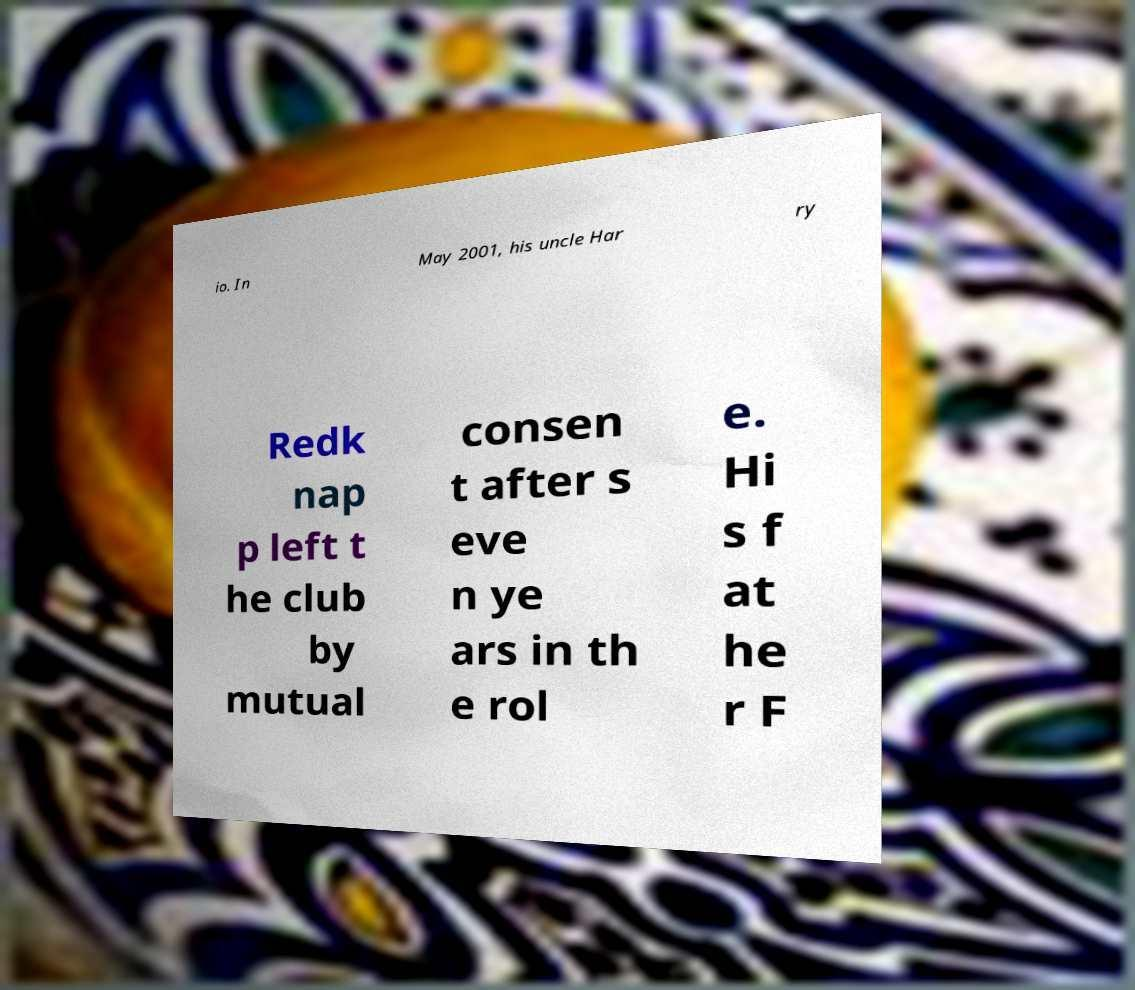Could you assist in decoding the text presented in this image and type it out clearly? io. In May 2001, his uncle Har ry Redk nap p left t he club by mutual consen t after s eve n ye ars in th e rol e. Hi s f at he r F 